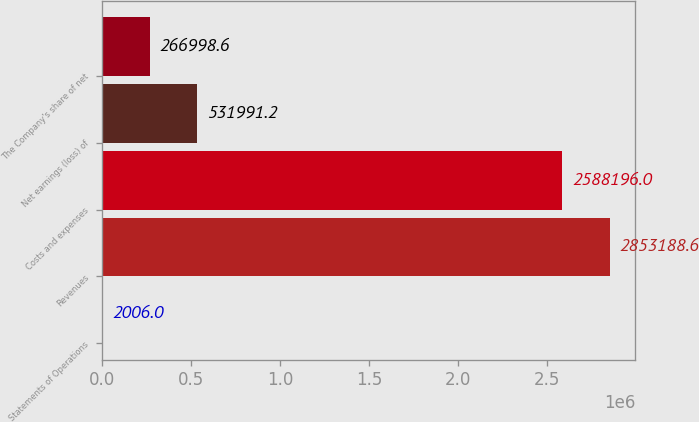<chart> <loc_0><loc_0><loc_500><loc_500><bar_chart><fcel>Statements of Operations<fcel>Revenues<fcel>Costs and expenses<fcel>Net earnings (loss) of<fcel>The Company's share of net<nl><fcel>2006<fcel>2.85319e+06<fcel>2.5882e+06<fcel>531991<fcel>266999<nl></chart> 